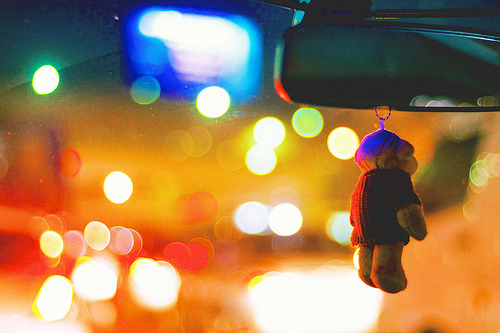<image>
Is there a light next to the monkey? No. The light is not positioned next to the monkey. They are located in different areas of the scene. Is the light behind the toy? Yes. From this viewpoint, the light is positioned behind the toy, with the toy partially or fully occluding the light. Is the bear in front of the mirror? No. The bear is not in front of the mirror. The spatial positioning shows a different relationship between these objects. 